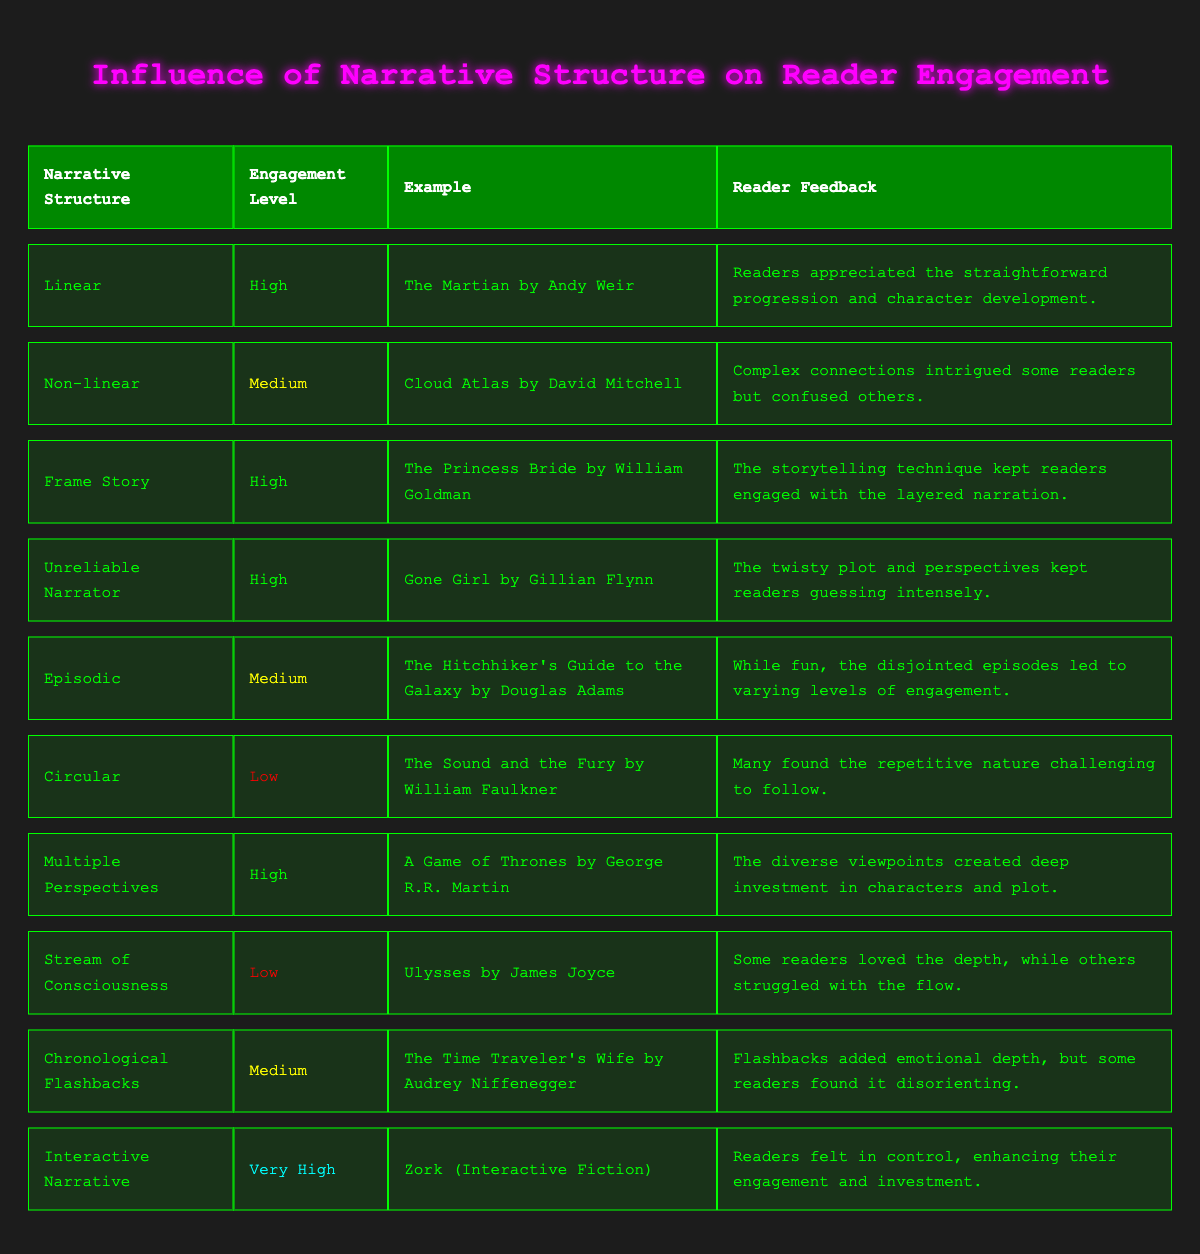What is the engagement level of the narrative structure "Circular"? The table shows that the engagement level of "Circular" is "Low", as indicated in the corresponding row for this structure.
Answer: Low Which narrative structure has the highest engagement level? The table lists "Interactive Narrative" as having the engagement level of "Very High", which is the highest compared to other structures.
Answer: Interactive Narrative How many narrative structures are rated as high engagement? By counting the rows labeled as "High" in the engagement level column, there are four structures: Linear, Frame Story, Unreliable Narrator, and Multiple Perspectives.
Answer: 4 Which narrative structure has an example related to an unreliable narrator? The table states that "Gone Girl by Gillian Flynn" is an example of the narrative structure "Unreliable Narrator", allowing us to identify the structure directly from the example.
Answer: Unreliable Narrator Are there any structures with a medium engagement level that provide emotional depth through flashbacks? Yes, "Chronological Flashbacks" is one such structure that has a medium engagement level and is noted for adding emotional depth through its use of flashbacks.
Answer: Yes What are the engagement levels of narrative structures that have examples featuring both high and low engagement? The high engagement structures are: Linear, Frame Story, Unreliable Narrator, Multiple Perspectives, and the low engagement structures include Circular and Stream of Consciousness. This provides a diversity of engagement levels among the examples.
Answer: High and Low What structure has a "Very High" engagement level, and what feedback did readers give? The table indicates that "Interactive Narrative" has a "Very High" engagement level, with feedback stating that readers felt in control, which enhanced their engagement and investment.
Answer: Interactive Narrative; readers felt in control Which narrative structure with a low engagement level did some readers struggle with due to flow? According to the table, "Stream of Consciousness" is the narrative structure with a low engagement level cited for causing struggles with flow among some readers.
Answer: Stream of Consciousness How does the engagement level of "Non-linear" compare to the others? The table categorizes "Non-linear" as "Medium," which means it is not as engaging as those rated as High or Very High, placing it between the lowest engagement level of Circular and those that are rated higher.
Answer: Medium 